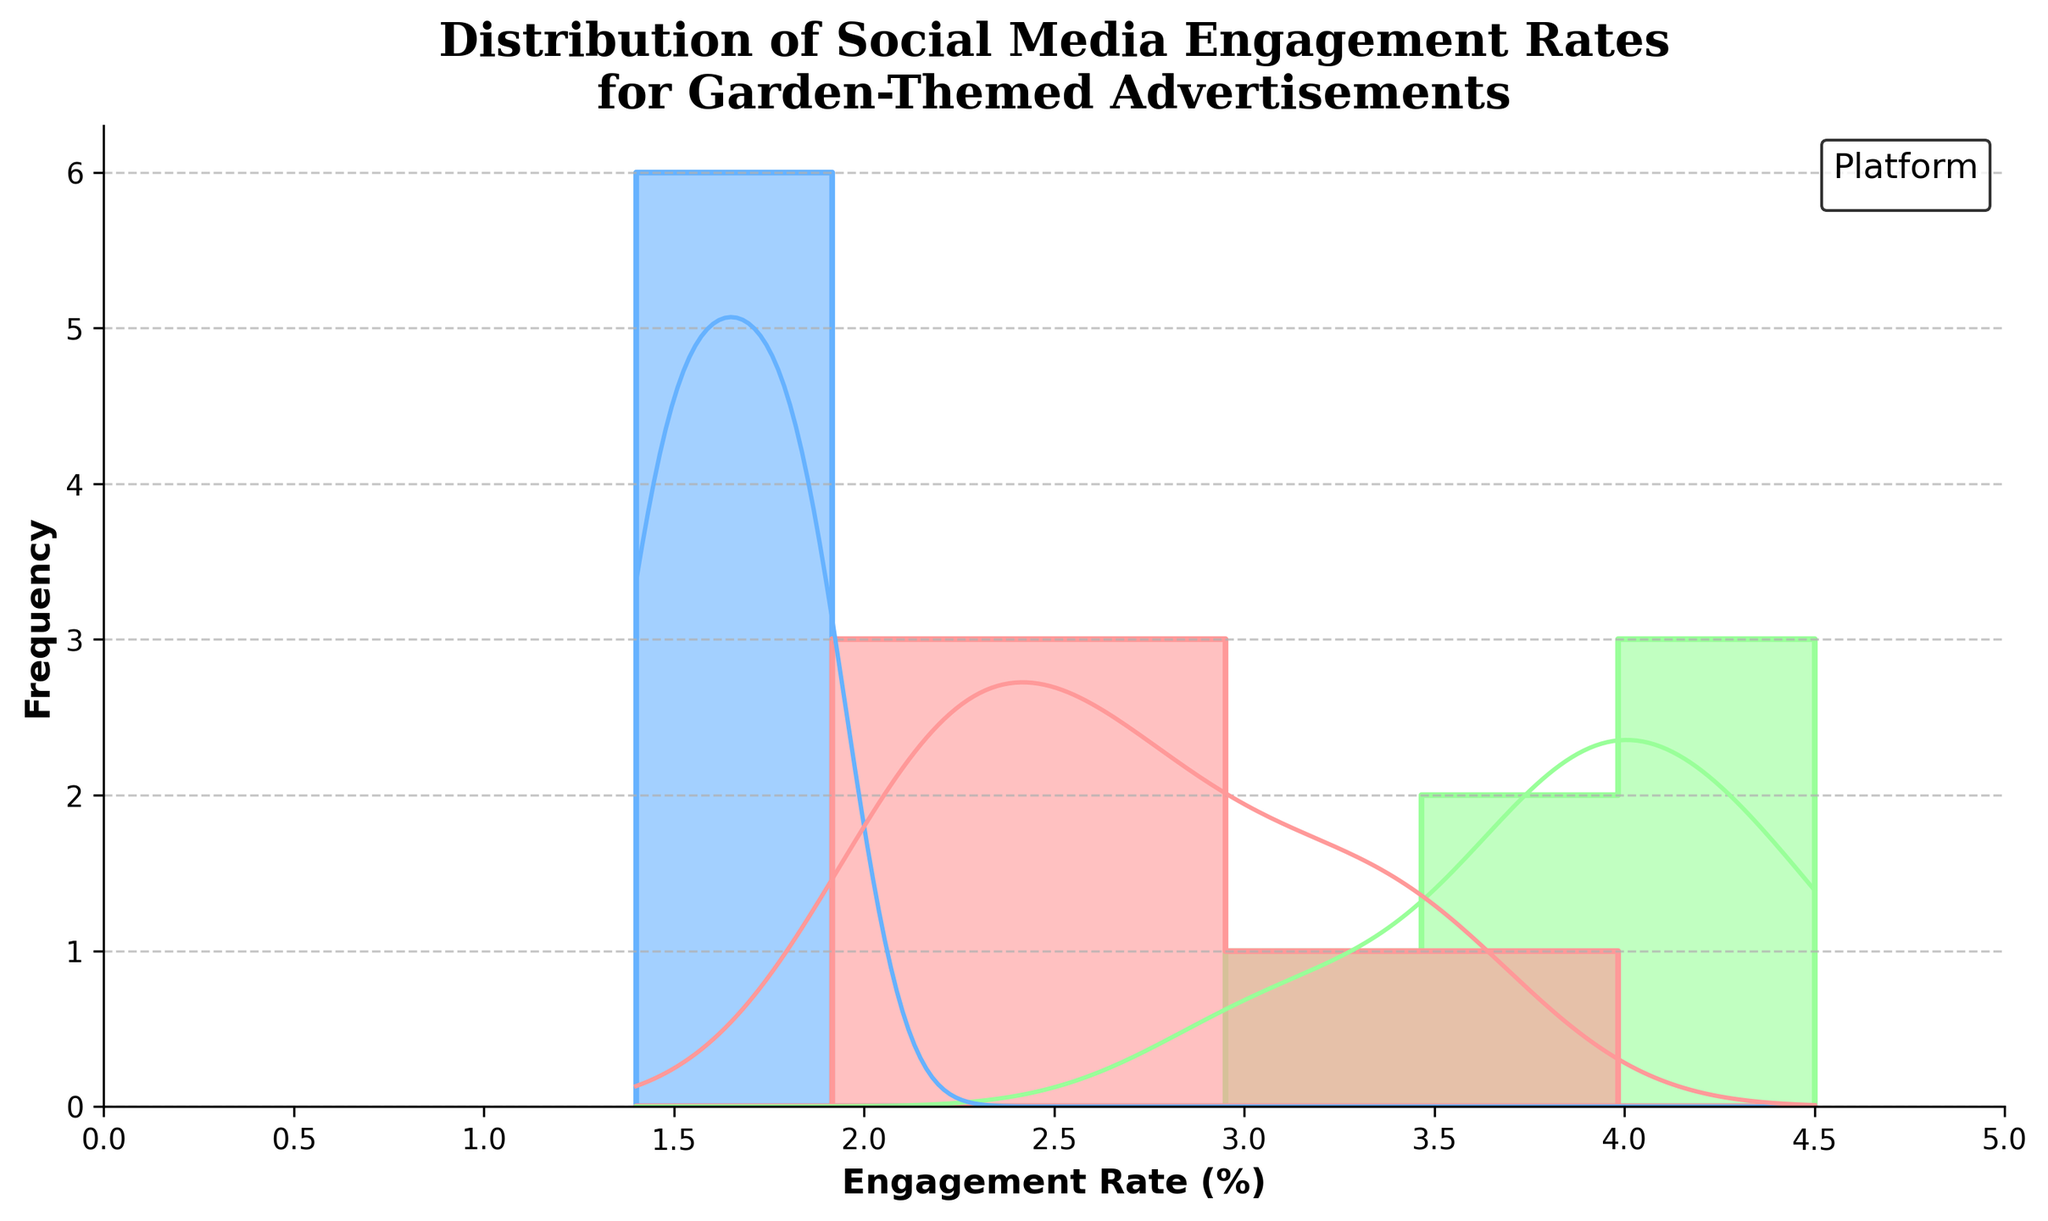What is the title of the figure? The title of the figure is displayed right at the top in bold, serif font. It provides a concise summary of what the figure represents.
Answer: Distribution of Social Media Engagement Rates for Garden-Themed Advertisements What is the range of the x-axis? The x-axis represents the engagement rate, and its range can be determined by looking at the labeled ticks at the bottom of the figure.
Answer: 0 to 5 Which platform has the highest engagement rate peak in the density curve? By looking at the density curves (KDE), the platform with the highest peak can be identified. Identify the color of the curves and see which curve reaches the highest point.
Answer: Pinterest How many different platforms are represented in the figure? The legend indicates different colors labeled with the platform names. Counting the distinct entries will give the number of platforms.
Answer: 3 What color represents Instagram in the histogram? The legend on the top right of the figure assigns colors to the platforms, and we can see which color is assigned to Instagram.
Answer: Light red Which platform shows an engagement rate that rarely exceeds 2.0 in the histogram? By observing the histogram bars and density curves, we'll look for the platform whose bars/densities mostly reside below the 2.0 engagement rate mark.
Answer: Facebook What is the approximate engagement rate range where Facebook shows the highest density in its KDE curve? The density curve for Facebook can be identified by its position and color. By looking at the peak point of this curve, we can determine the range where it is highest.
Answer: 1.5 to 2.0 Which two platforms have overlapping engagement rate ranges, and what are those ranges? By examining the histogram and KDE curves, we can identify which platforms share similar ranges. Note the engagement rate intervals for overlapping regions.
Answer: Instagram and Facebook; 1.5 to 2.3 Is there any platform with an engagement rate consistently above 4.0? Observing the KDE curves and histogram bars can help determine if any platform has a substantial representation above the 4.0 engagement rate unit.
Answer: Pinterest Which platform shows the most variability in engagement rates? Variability can be judged by the spread of the histogram and the distribution shown by the density curve. The platform with the widest spread has the most variability.
Answer: Pinterest 